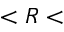<formula> <loc_0><loc_0><loc_500><loc_500>< R <</formula> 